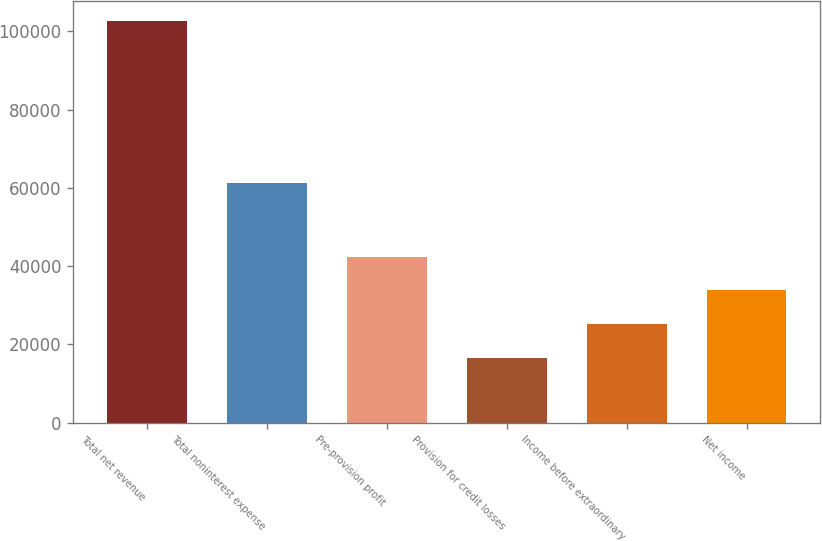Convert chart. <chart><loc_0><loc_0><loc_500><loc_500><bar_chart><fcel>Total net revenue<fcel>Total noninterest expense<fcel>Pre-provision profit<fcel>Provision for credit losses<fcel>Income before extraordinary<fcel>Net income<nl><fcel>102694<fcel>61196<fcel>42455.5<fcel>16639<fcel>25244.5<fcel>33850<nl></chart> 